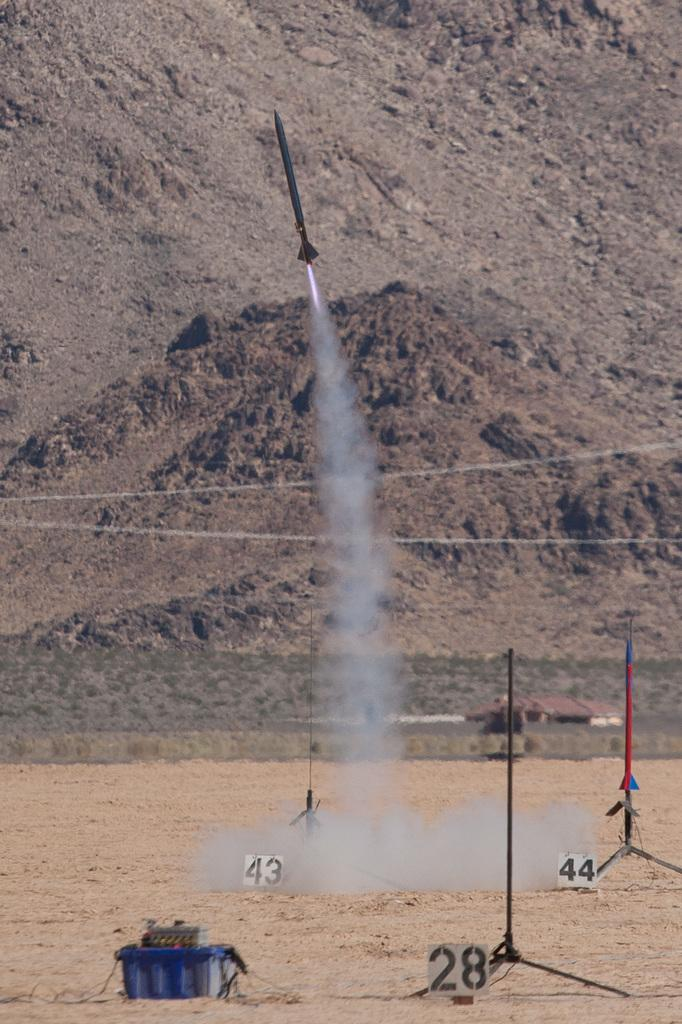What is the main subject of the image? The main subject of the image is a rocket flying. What can be seen around the rocket? There is smoke in the image. What else is present in the image besides the rocket and smoke? There are stands with numbers and a box on the ground. What is visible in the background of the image? There is a hill in the background of the image. Where is the actor standing in the image? There is no actor present in the image. What type of brush can be seen in the image? There is no brush present in the image. 